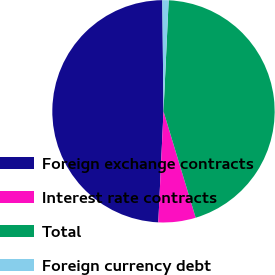Convert chart to OTSL. <chart><loc_0><loc_0><loc_500><loc_500><pie_chart><fcel>Foreign exchange contracts<fcel>Interest rate contracts<fcel>Total<fcel>Foreign currency debt<nl><fcel>49.09%<fcel>5.42%<fcel>44.58%<fcel>0.91%<nl></chart> 